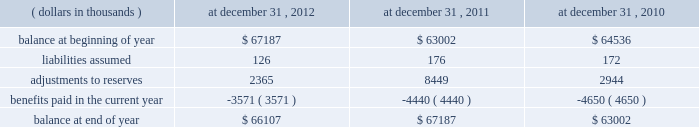At december 31 , 2012 , the gross reserves for a&e losses were comprised of $ 138449 thousand representing case reserves reported by ceding companies , $ 90637 thousand representing additional case reserves established by the company on assumed reinsurance claims , $ 36667 thousand representing case reserves established by the company on direct excess insurance claims , including mt .
Mckinley , and $ 177068 thousand representing ibnr reserves .
With respect to asbestos only , at december 31 , 2012 , the company had gross asbestos loss reserves of $ 422849 thousand , or 95.5% ( 95.5 % ) , of total a&e reserves , of which $ 339654 thousand was for assumed business and $ 83195 thousand was for direct business .
Future policy benefit reserve .
Activity in the reserve for future policy benefits is summarized for the periods indicated: .
Fair value the company 2019s fixed maturity and equity securities are primarily managed by third party investment asset managers .
The investment asset managers obtain prices from nationally recognized pricing services .
These services seek to utilize market data and observations in their evaluation process .
They use pricing applications that vary by asset class and incorporate available market information and when fixed maturity securities do not trade on a daily basis the services will apply available information through processes such as benchmark curves , benchmarking of like securities , sector groupings and matrix pricing .
In addition , they use model processes , such as the option adjusted spread model to develop prepayment and interest rate scenarios for securities that have prepayment features .
In limited instances where prices are not provided by pricing services or in rare instances when a manager may not agree with the pricing service , price quotes on a non-binding basis are obtained from investment brokers .
The investment asset managers do not make any changes to prices received from either the pricing services or the investment brokers .
In addition , the investment asset managers have procedures in place to review the reasonableness of the prices from the service providers and may request verification of the prices .
In addition , the company continually performs analytical reviews of price changes and tests the prices on a random basis to an independent pricing source .
No material variances were noted during these price validation procedures .
In limited situations , where financial markets are inactive or illiquid , the company may use its own assumptions about future cash flows and risk-adjusted discount rates to determine fair value .
The company made no such adjustments at december 31 , 2012 and 2011 .
The company internally manages a small public equity portfolio which had a fair value at december 31 , 2012 of $ 117602 thousand and all prices were obtained from publically published sources .
Equity securities in u.s .
Denominated currency are categorized as level 1 , quoted prices in active markets for identical assets , since the securities are actively traded on an exchange and prices are based on quoted prices from the exchange .
Equity securities traded on foreign exchanges are categorized as level 2 due to potential foreign exchange adjustments to fair or market value .
Fixed maturity securities are generally categorized as level 2 , significant other observable inputs , since a particular security may not have traded but the pricing services are able to use valuation models with observable market inputs such as interest rate yield curves and prices for similar fixed maturity securities in terms of issuer , maturity and seniority .
Valuations that are derived from techniques in which one or more of the significant inputs are unobservable ( including assumptions about risk ) are categorized as level 3 .
What is the net change in reserve for future policy benefits during 2012? 
Computations: (66107 - 67187)
Answer: -1080.0. At december 31 , 2012 , the gross reserves for a&e losses were comprised of $ 138449 thousand representing case reserves reported by ceding companies , $ 90637 thousand representing additional case reserves established by the company on assumed reinsurance claims , $ 36667 thousand representing case reserves established by the company on direct excess insurance claims , including mt .
Mckinley , and $ 177068 thousand representing ibnr reserves .
With respect to asbestos only , at december 31 , 2012 , the company had gross asbestos loss reserves of $ 422849 thousand , or 95.5% ( 95.5 % ) , of total a&e reserves , of which $ 339654 thousand was for assumed business and $ 83195 thousand was for direct business .
Future policy benefit reserve .
Activity in the reserve for future policy benefits is summarized for the periods indicated: .
Fair value the company 2019s fixed maturity and equity securities are primarily managed by third party investment asset managers .
The investment asset managers obtain prices from nationally recognized pricing services .
These services seek to utilize market data and observations in their evaluation process .
They use pricing applications that vary by asset class and incorporate available market information and when fixed maturity securities do not trade on a daily basis the services will apply available information through processes such as benchmark curves , benchmarking of like securities , sector groupings and matrix pricing .
In addition , they use model processes , such as the option adjusted spread model to develop prepayment and interest rate scenarios for securities that have prepayment features .
In limited instances where prices are not provided by pricing services or in rare instances when a manager may not agree with the pricing service , price quotes on a non-binding basis are obtained from investment brokers .
The investment asset managers do not make any changes to prices received from either the pricing services or the investment brokers .
In addition , the investment asset managers have procedures in place to review the reasonableness of the prices from the service providers and may request verification of the prices .
In addition , the company continually performs analytical reviews of price changes and tests the prices on a random basis to an independent pricing source .
No material variances were noted during these price validation procedures .
In limited situations , where financial markets are inactive or illiquid , the company may use its own assumptions about future cash flows and risk-adjusted discount rates to determine fair value .
The company made no such adjustments at december 31 , 2012 and 2011 .
The company internally manages a small public equity portfolio which had a fair value at december 31 , 2012 of $ 117602 thousand and all prices were obtained from publically published sources .
Equity securities in u.s .
Denominated currency are categorized as level 1 , quoted prices in active markets for identical assets , since the securities are actively traded on an exchange and prices are based on quoted prices from the exchange .
Equity securities traded on foreign exchanges are categorized as level 2 due to potential foreign exchange adjustments to fair or market value .
Fixed maturity securities are generally categorized as level 2 , significant other observable inputs , since a particular security may not have traded but the pricing services are able to use valuation models with observable market inputs such as interest rate yield curves and prices for similar fixed maturity securities in terms of issuer , maturity and seniority .
Valuations that are derived from techniques in which one or more of the significant inputs are unobservable ( including assumptions about risk ) are categorized as level 3 .
What is the net change in reserve for future policy benefits during 2011? 
Computations: (67187 - 63002)
Answer: 4185.0. 